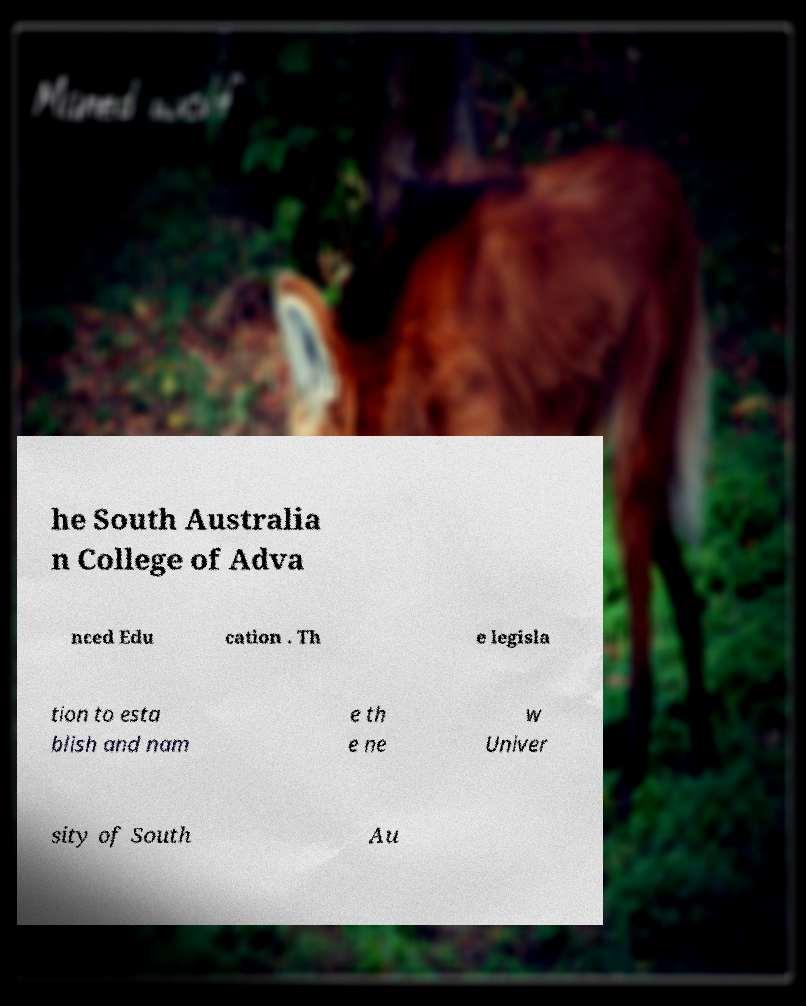Please identify and transcribe the text found in this image. he South Australia n College of Adva nced Edu cation . Th e legisla tion to esta blish and nam e th e ne w Univer sity of South Au 